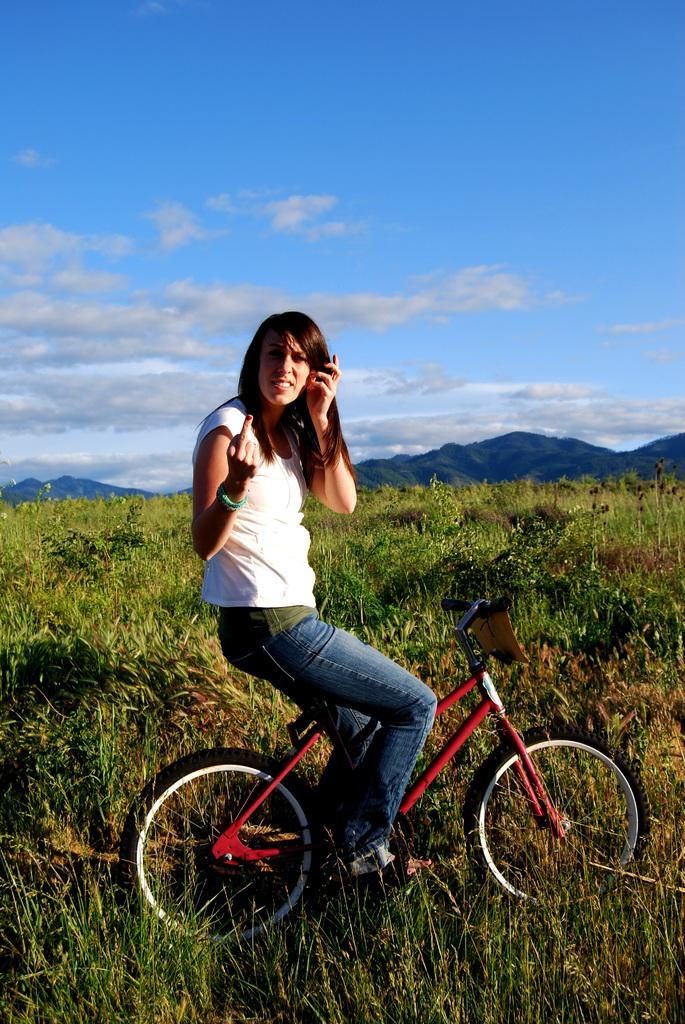Who is the main subject in the image? There is a woman in the image. What is the woman doing in the image? The woman is sitting on a cycle. Where is the cycle located? The cycle is on the grassland. What can be seen in the background of the image? There is sky, clouds, and hills visible in the background of the image. What is the profit made by the car in the image? There is no car present in the image, so there is no profit to discuss. Can you tell me the type of rock the woman is sitting on in the image? The image does not provide information about the type of rock, if any, that the woman is sitting on. 